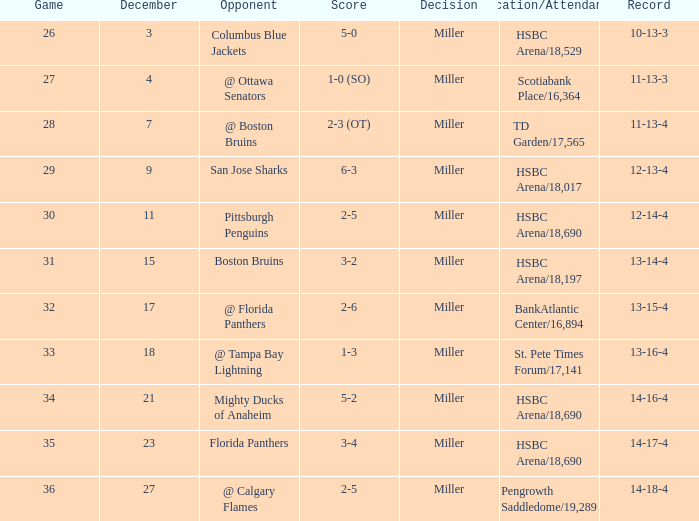Name the score for 29 game 6-3. 